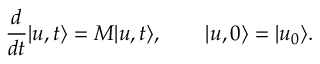<formula> <loc_0><loc_0><loc_500><loc_500>\frac { d } { d t } | u , t \rangle = M | u , t \rangle , \quad | u , 0 \rangle = | u _ { 0 } \rangle .</formula> 